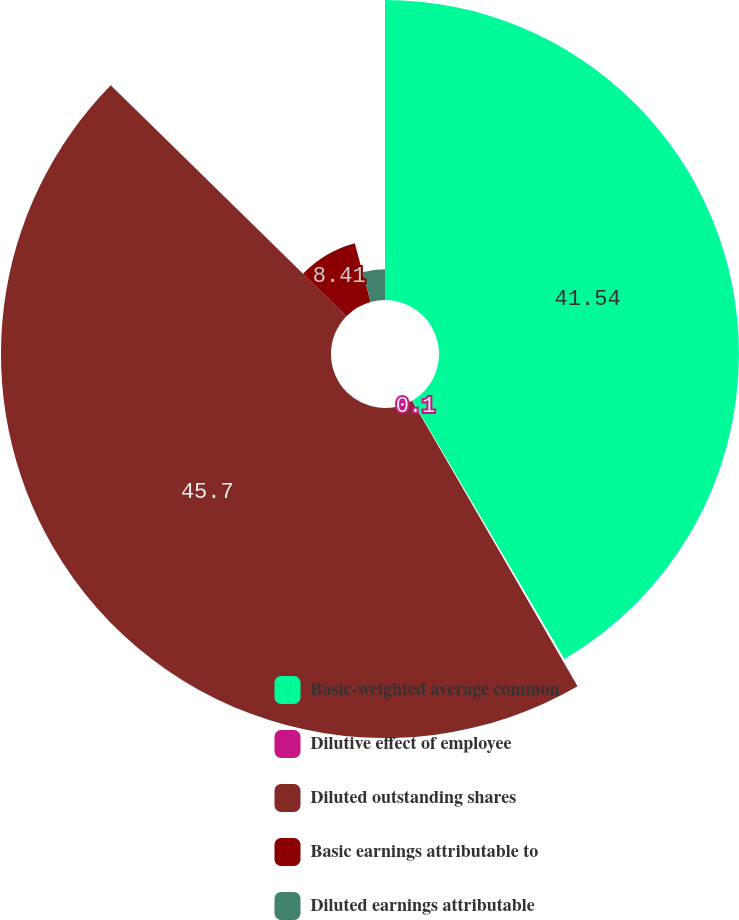Convert chart. <chart><loc_0><loc_0><loc_500><loc_500><pie_chart><fcel>Basic-weighted average common<fcel>Dilutive effect of employee<fcel>Diluted outstanding shares<fcel>Basic earnings attributable to<fcel>Diluted earnings attributable<nl><fcel>41.54%<fcel>0.1%<fcel>45.7%<fcel>8.41%<fcel>4.25%<nl></chart> 